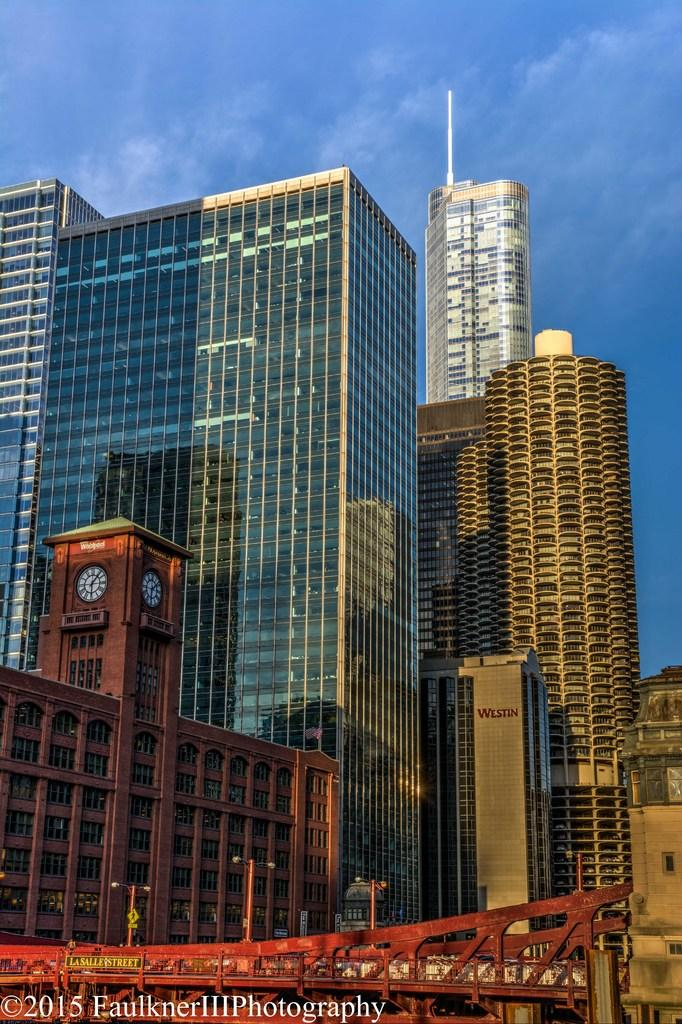What type of structures can be seen in the image? There are many buildings and towers in the image. What is visible at the top of the image? The sky is visible at the top of the image, with some clouds. What color is the bridge at the bottom of the image? The bridge at the bottom of the image is red. What additional detail can be seen in the image? A logo is visible in the image. How many clams are sitting on the bridge in the image? There are no clams present in the image; it features a red bridge with no visible sea creatures. What type of fruit is hanging from the towers in the image? There are no fruits hanging from the towers in the image; they are tall structures with no visible produce. 